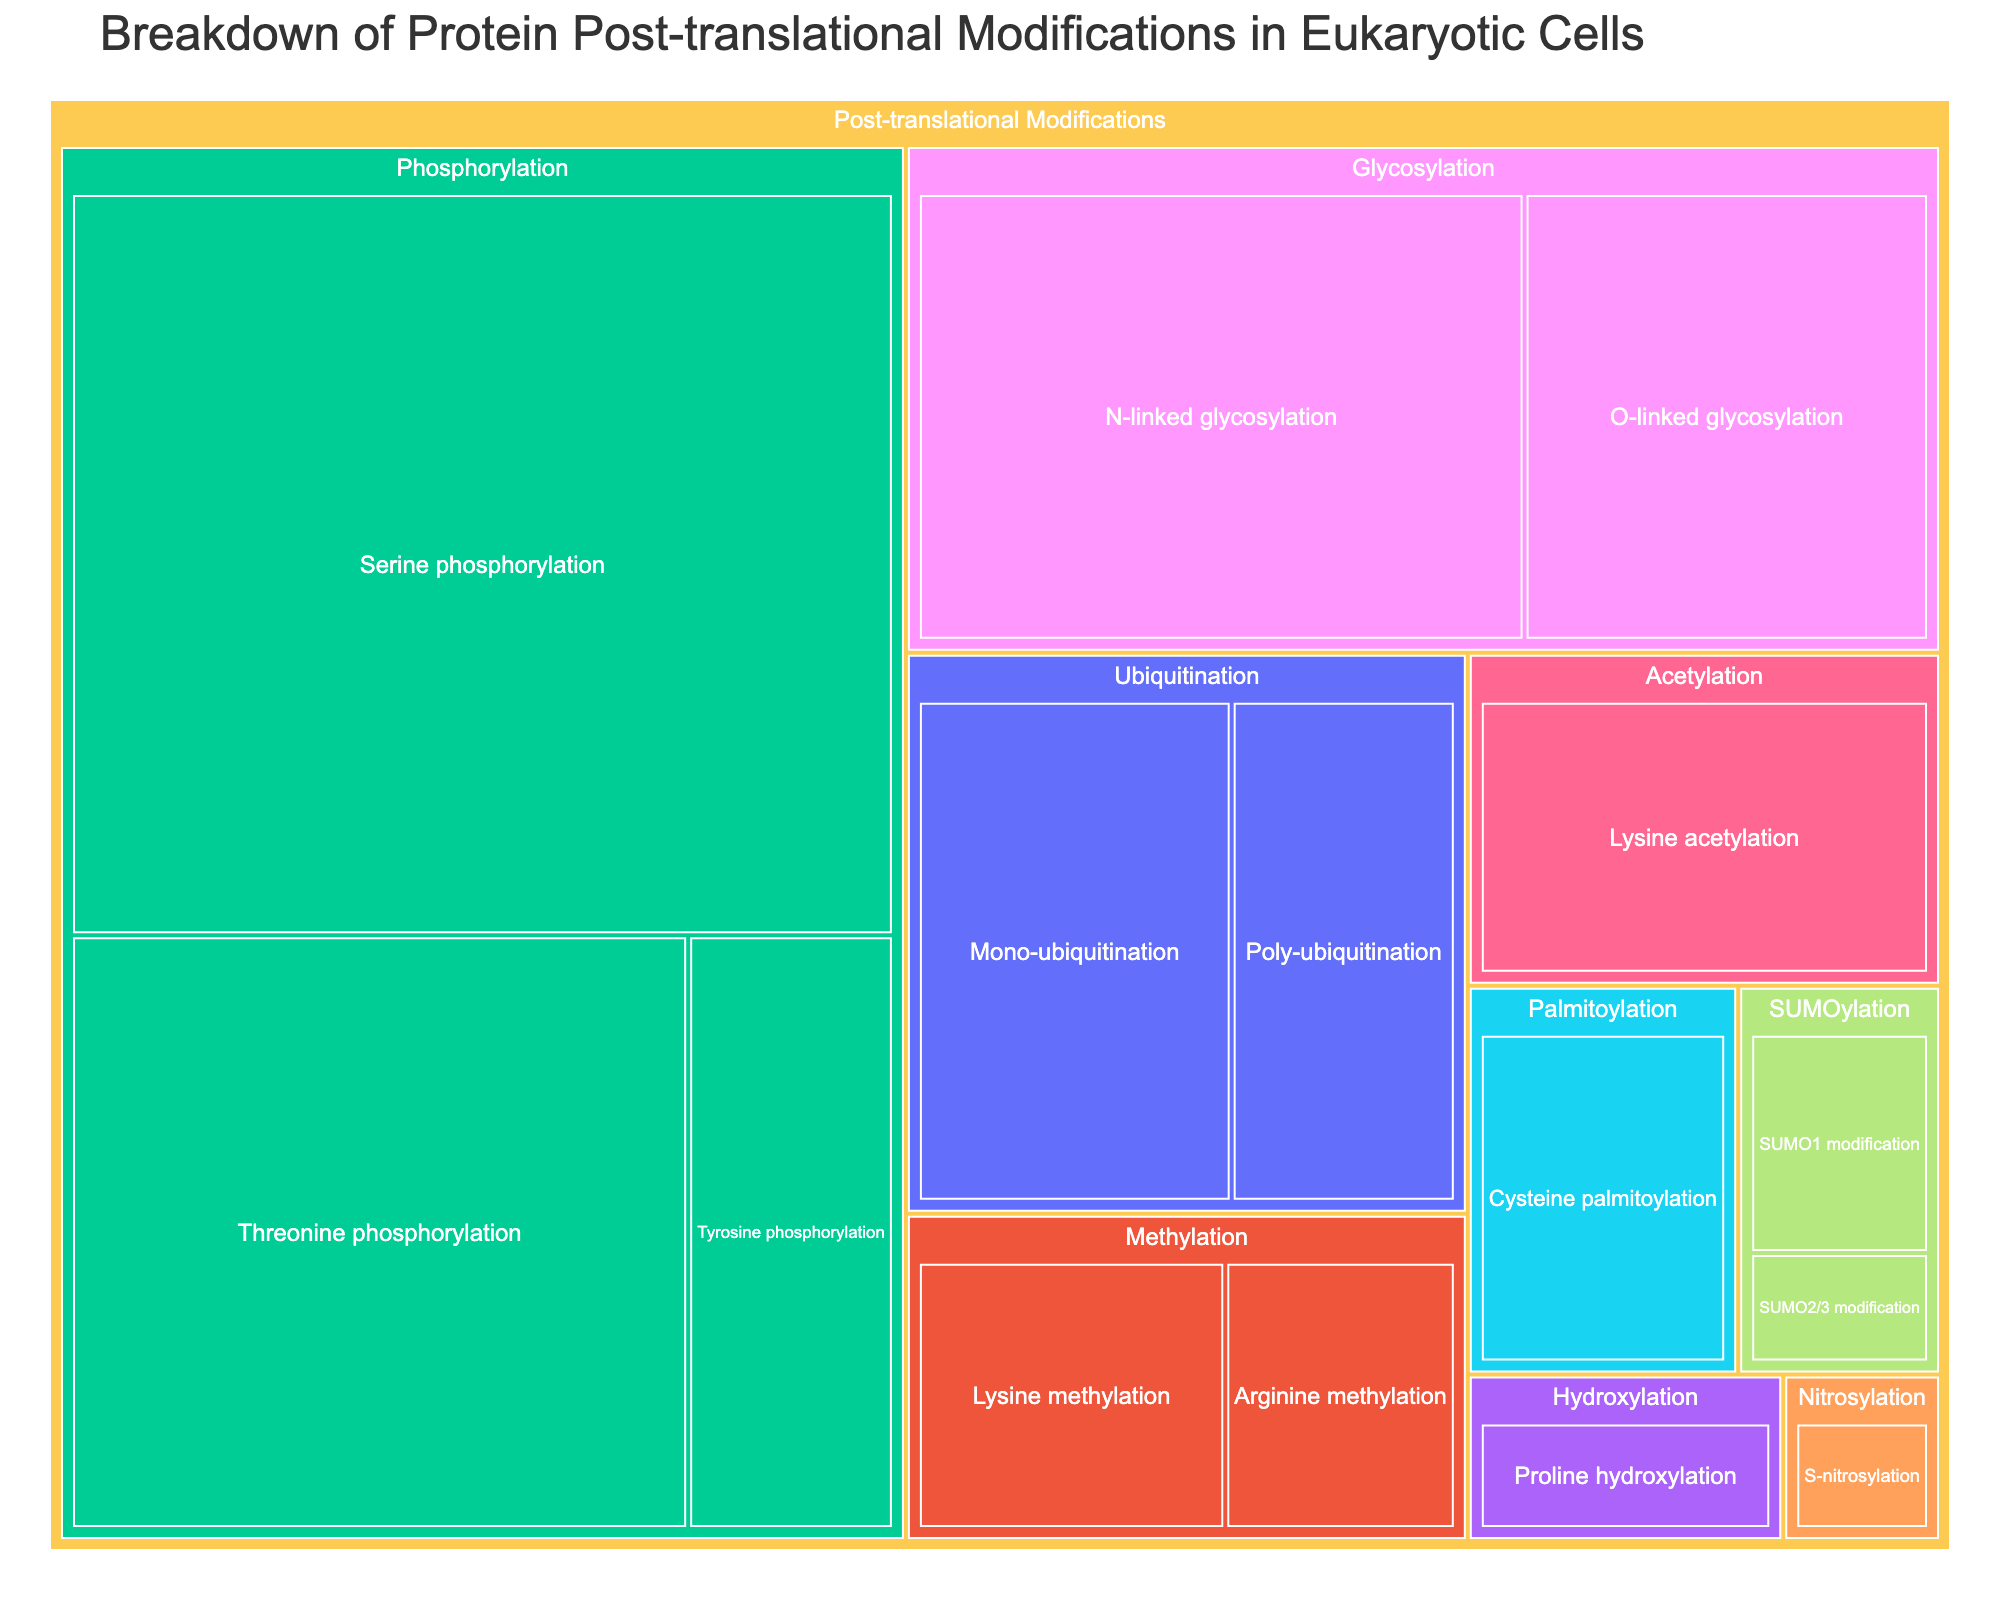What is the title of the Treemap? The title of the Treemap is typically located at the top of the visual representation and is written in larger font size compared to the rest of the text. The title should clearly state the main subject of the data being shown in the Treemap.
Answer: Breakdown of Protein Post-translational Modifications in Eukaryotic Cells Which subtype of modification has the highest percentage? Look at the subtypes within the Treemap and identify the one with the largest area, as area size corresponds to the percentage. The label and hovering details can also help.
Answer: Serine phosphorylation What is the total percentage of Glycosylation modifications? Combine the percentages of all subtypes under Glycosylation by adding them up. For Glycosylation, the subtypes are N-linked glycosylation (12%) and O-linked glycosylation (8%). So, the total is 12% + 8% = 20%.
Answer: 20% Which two modification types contribute to 10% individually and cumulatively total to 20%? Look for individual subtypes equal to 10% and add their percentages. However, there’s no individual subtype with 10% alone; collectively 2 subtypes form Glycosylation types (12% + 8%) which make the cumulative total.
Answer: O-linked glycosylation and N-linked glycosylation Which modification type has the fewest subtypes? Count the number of subtypes for each modification type. The one with the fewest will stand out. For example, Nitrosylation has only one subtype, which is S-nitrosylation.
Answer: Nitrosylation How many subtypes are there in total? Count all the subtypes listed in the Treemap by checking each modification type. Phosphorylation has 3, Glycosylation has 2, Ubiquitination has 2, Acetylation has 1, Methylation has 2, SUMOylation has 2, Nitrosylation has 1, Hydroxylation has 1, and Palmitoylation has 1. Adding these gives 3 + 2 + 2 + 1 + 2 + 2 + 1 + 1 + 1 = 15.
Answer: 15 Compare the percentage of Summoylation with Nitrosylation. Which one has a higher percentage? Check the values given for SUMOylation and Nitrosylation. SUMOylation (SUMO1 modification: 2%, SUMO2/3 modification: 1%) has a total of 3%, while Nitrosylation (S-nitrosylation: 1%) is only 1%. So, SUMOylation is higher.
Answer: SUMOylation What is the percentage of Lysine modifications (Acetylation and Methylation combined)? Add the percentage values of Lysine acetylation (6%) with Lysine methylation (4%). Therefore, the total percentage is 6% + 4% = 10%.
Answer: 10% 